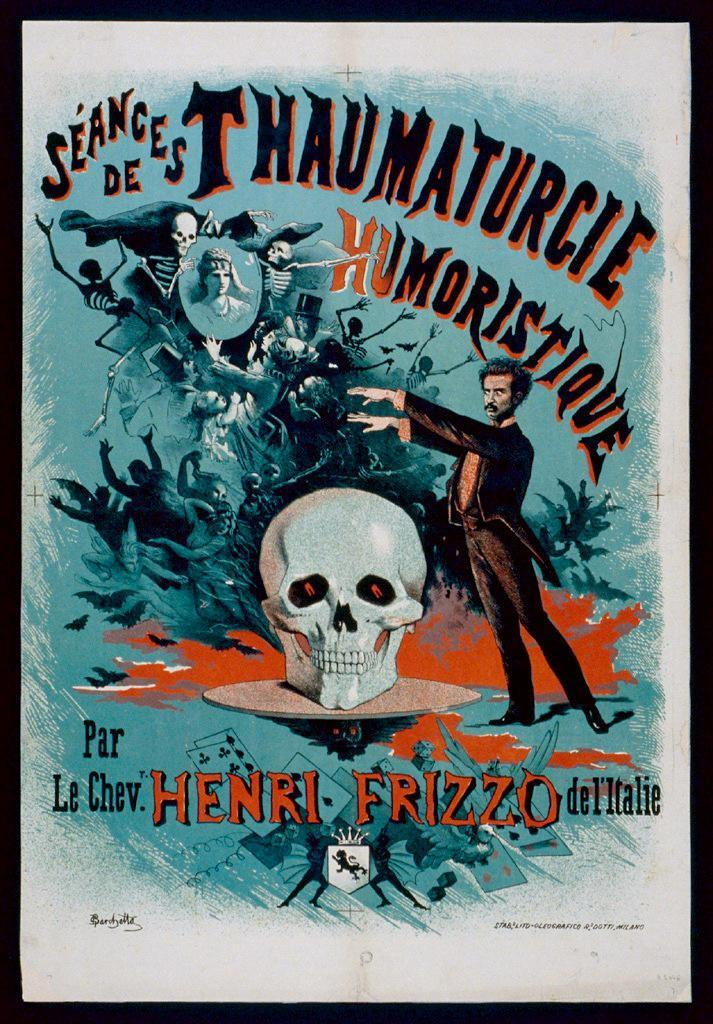<image>
Describe the image concisely. A cartoon poster for Seances de Thaumaturcie Humoristique. 